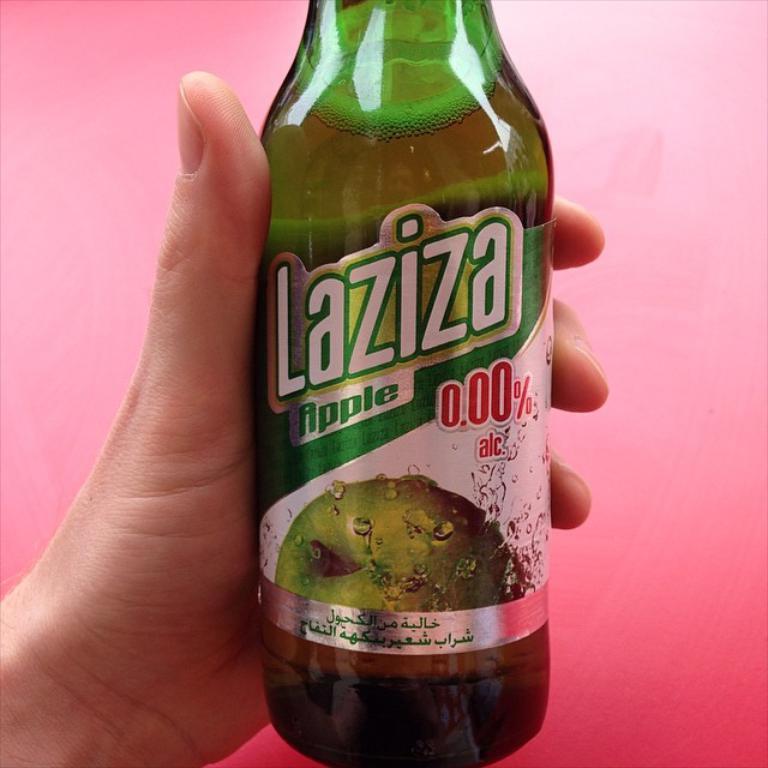Can you describe this image briefly? In this image there is one bottle, and it seems that one person is holding that bottle. 